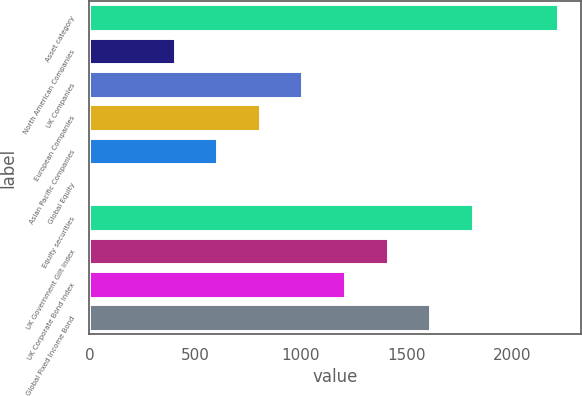<chart> <loc_0><loc_0><loc_500><loc_500><bar_chart><fcel>Asset category<fcel>North American Companies<fcel>UK Companies<fcel>European Companies<fcel>Asian Pacific Companies<fcel>Global Equity<fcel>Equity securities<fcel>UK Government Gilt Index<fcel>UK Corporate Bond Index<fcel>Global Fixed Income Bond<nl><fcel>2213.1<fcel>403.2<fcel>1006.5<fcel>805.4<fcel>604.3<fcel>1<fcel>1810.9<fcel>1408.7<fcel>1207.6<fcel>1609.8<nl></chart> 